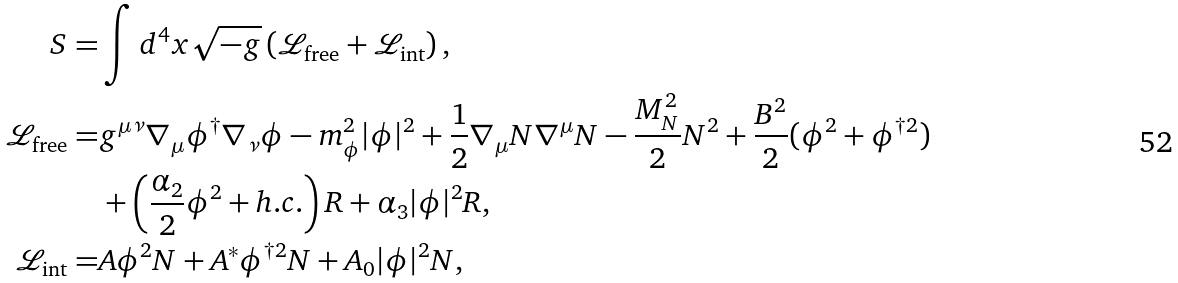<formula> <loc_0><loc_0><loc_500><loc_500>S = & \int d ^ { 4 } x \sqrt { - g } \left ( \mathcal { L } _ { \text {free} } + \mathcal { L } _ { \text {int} } \right ) , \\ \mathcal { L } _ { \text {free} } = & g ^ { \mu \nu } \nabla _ { \mu } \phi ^ { \dagger } \nabla _ { \nu } \phi - m _ { \phi } ^ { 2 } | \phi | ^ { 2 } + \frac { 1 } { 2 } \nabla _ { \mu } N \nabla ^ { \mu } N - \frac { M _ { N } ^ { 2 } } { 2 } N ^ { 2 } + \frac { B ^ { 2 } } { 2 } ( \phi ^ { 2 } + \phi ^ { \dagger 2 } ) \\ & + \left ( \frac { \alpha _ { 2 } } { 2 } \phi ^ { 2 } + h . c . \right ) R + \alpha _ { 3 } | \phi | ^ { 2 } R , \\ \mathcal { L } _ { \text {int} } = & A \phi ^ { 2 } N + A ^ { \ast } \phi ^ { \dagger 2 } N + A _ { 0 } | \phi | ^ { 2 } N ,</formula> 